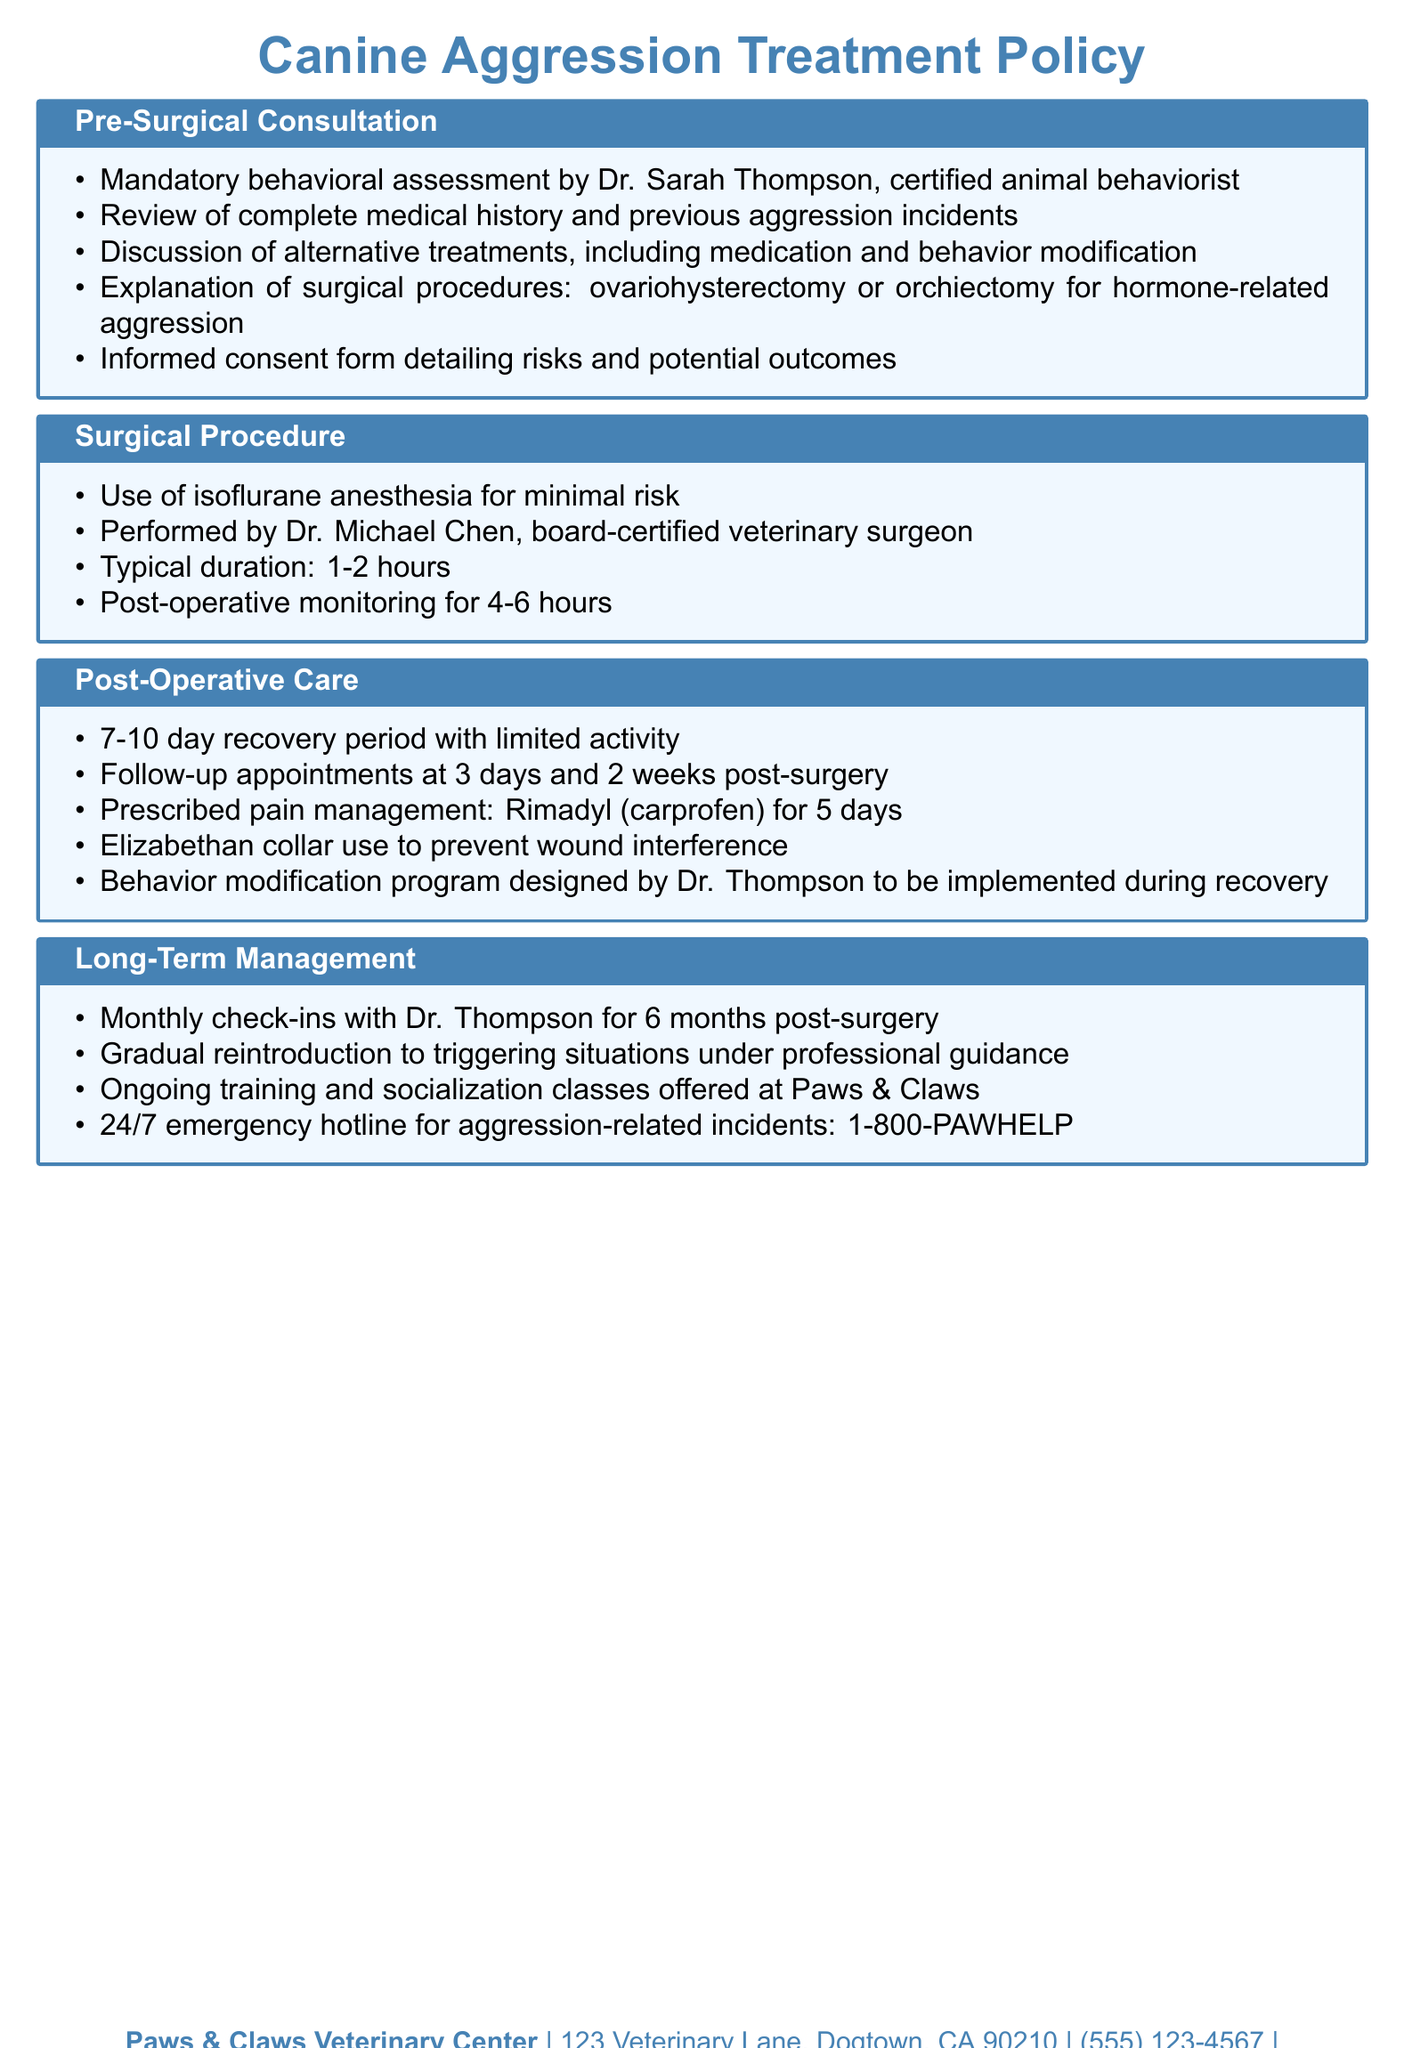What is the profession of Dr. Sarah Thompson? Dr. Sarah Thompson is identified as a certified animal behaviorist in the document.
Answer: certified animal behaviorist How long does the surgical procedure typically take? The document states that the typical duration of the surgical procedure is 1-2 hours.
Answer: 1-2 hours What pain management medication is prescribed post-surgery? The document mentions that Rimadyl (carprofen) is prescribed for pain management for 5 days.
Answer: Rimadyl (carprofen) How many follow-up appointments are scheduled after surgery? According to the document, there are follow-up appointments at 3 days and 2 weeks post-surgery, making it a total of two appointments.
Answer: two appointments What is required during the post-operative recovery period? The document specifies that there is a 7-10 day recovery period with limited activity during this time.
Answer: limited activity What is offered for long-term management of aggressive behaviors? The document states that ongoing training and socialization classes are offered at Paws & Claws for long-term management.
Answer: training and socialization classes What type of anesthesia is used for the surgical procedure? The document states that isoflurane anesthesia is used for minimal risk during the surgery.
Answer: isoflurane anesthesia How often are check-ins scheduled with Dr. Thompson after surgery? The document indicates that monthly check-ins with Dr. Thompson are scheduled for 6 months post-surgery.
Answer: monthly check-ins for 6 months 